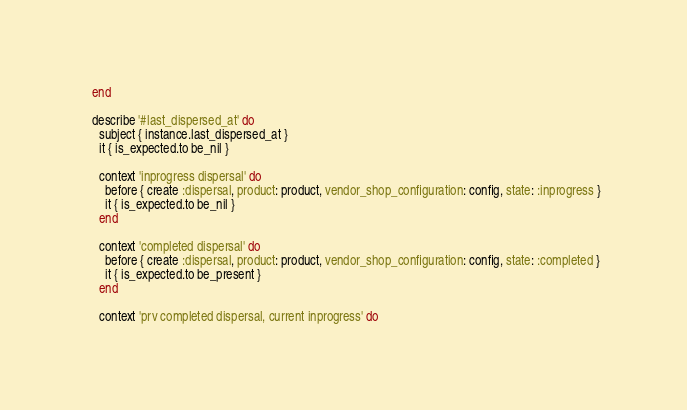<code> <loc_0><loc_0><loc_500><loc_500><_Ruby_>  end

  describe '#last_dispersed_at' do
    subject { instance.last_dispersed_at }
    it { is_expected.to be_nil }

    context 'inprogress dispersal' do
      before { create :dispersal, product: product, vendor_shop_configuration: config, state: :inprogress }
      it { is_expected.to be_nil }
    end

    context 'completed dispersal' do
      before { create :dispersal, product: product, vendor_shop_configuration: config, state: :completed }
      it { is_expected.to be_present }
    end

    context 'prv completed dispersal, current inprogress' do</code> 